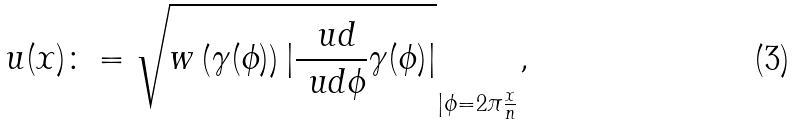Convert formula to latex. <formula><loc_0><loc_0><loc_500><loc_500>u ( x ) \colon = \sqrt { w \left ( \gamma ( \phi ) \right ) | \frac { \ u d } { \ u d \phi } \gamma ( \phi ) | } _ { | \phi = 2 \pi \frac { x } { n } } ,</formula> 